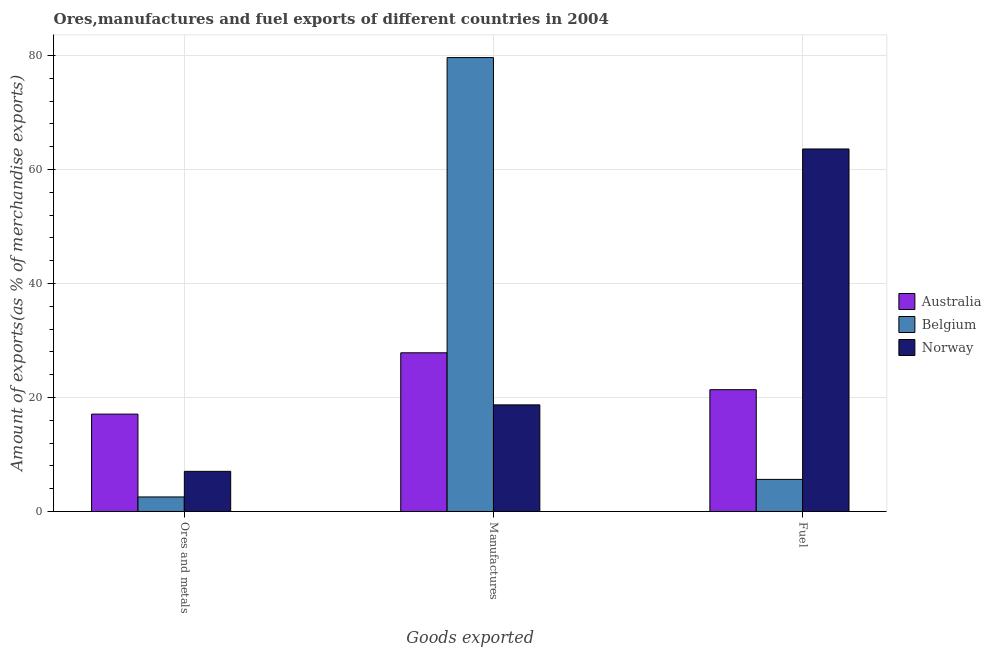How many groups of bars are there?
Offer a terse response. 3. Are the number of bars per tick equal to the number of legend labels?
Your answer should be very brief. Yes. How many bars are there on the 1st tick from the right?
Give a very brief answer. 3. What is the label of the 1st group of bars from the left?
Provide a short and direct response. Ores and metals. What is the percentage of fuel exports in Belgium?
Make the answer very short. 5.63. Across all countries, what is the maximum percentage of manufactures exports?
Your answer should be compact. 79.65. Across all countries, what is the minimum percentage of manufactures exports?
Your answer should be compact. 18.71. In which country was the percentage of manufactures exports maximum?
Ensure brevity in your answer.  Belgium. In which country was the percentage of ores and metals exports minimum?
Give a very brief answer. Belgium. What is the total percentage of fuel exports in the graph?
Ensure brevity in your answer.  90.62. What is the difference between the percentage of manufactures exports in Norway and that in Australia?
Make the answer very short. -9.14. What is the difference between the percentage of manufactures exports in Norway and the percentage of ores and metals exports in Belgium?
Keep it short and to the point. 16.16. What is the average percentage of ores and metals exports per country?
Offer a terse response. 8.89. What is the difference between the percentage of ores and metals exports and percentage of manufactures exports in Norway?
Make the answer very short. -11.66. What is the ratio of the percentage of fuel exports in Belgium to that in Norway?
Your answer should be compact. 0.09. Is the difference between the percentage of ores and metals exports in Australia and Belgium greater than the difference between the percentage of fuel exports in Australia and Belgium?
Your response must be concise. No. What is the difference between the highest and the second highest percentage of ores and metals exports?
Your answer should be compact. 10.04. What is the difference between the highest and the lowest percentage of fuel exports?
Provide a succinct answer. 57.98. Is the sum of the percentage of fuel exports in Norway and Belgium greater than the maximum percentage of ores and metals exports across all countries?
Offer a very short reply. Yes. What does the 3rd bar from the right in Manufactures represents?
Keep it short and to the point. Australia. Are all the bars in the graph horizontal?
Your answer should be compact. No. How many countries are there in the graph?
Make the answer very short. 3. What is the difference between two consecutive major ticks on the Y-axis?
Provide a short and direct response. 20. Does the graph contain any zero values?
Give a very brief answer. No. How many legend labels are there?
Provide a short and direct response. 3. How are the legend labels stacked?
Offer a terse response. Vertical. What is the title of the graph?
Make the answer very short. Ores,manufactures and fuel exports of different countries in 2004. What is the label or title of the X-axis?
Your response must be concise. Goods exported. What is the label or title of the Y-axis?
Provide a succinct answer. Amount of exports(as % of merchandise exports). What is the Amount of exports(as % of merchandise exports) of Australia in Ores and metals?
Offer a terse response. 17.09. What is the Amount of exports(as % of merchandise exports) of Belgium in Ores and metals?
Offer a terse response. 2.55. What is the Amount of exports(as % of merchandise exports) of Norway in Ores and metals?
Provide a short and direct response. 7.05. What is the Amount of exports(as % of merchandise exports) in Australia in Manufactures?
Ensure brevity in your answer.  27.85. What is the Amount of exports(as % of merchandise exports) in Belgium in Manufactures?
Make the answer very short. 79.65. What is the Amount of exports(as % of merchandise exports) in Norway in Manufactures?
Your response must be concise. 18.71. What is the Amount of exports(as % of merchandise exports) of Australia in Fuel?
Your response must be concise. 21.37. What is the Amount of exports(as % of merchandise exports) in Belgium in Fuel?
Make the answer very short. 5.63. What is the Amount of exports(as % of merchandise exports) in Norway in Fuel?
Provide a succinct answer. 63.61. Across all Goods exported, what is the maximum Amount of exports(as % of merchandise exports) of Australia?
Keep it short and to the point. 27.85. Across all Goods exported, what is the maximum Amount of exports(as % of merchandise exports) in Belgium?
Keep it short and to the point. 79.65. Across all Goods exported, what is the maximum Amount of exports(as % of merchandise exports) in Norway?
Offer a terse response. 63.61. Across all Goods exported, what is the minimum Amount of exports(as % of merchandise exports) in Australia?
Your response must be concise. 17.09. Across all Goods exported, what is the minimum Amount of exports(as % of merchandise exports) of Belgium?
Offer a terse response. 2.55. Across all Goods exported, what is the minimum Amount of exports(as % of merchandise exports) of Norway?
Your answer should be very brief. 7.05. What is the total Amount of exports(as % of merchandise exports) in Australia in the graph?
Give a very brief answer. 66.31. What is the total Amount of exports(as % of merchandise exports) of Belgium in the graph?
Your answer should be compact. 87.84. What is the total Amount of exports(as % of merchandise exports) in Norway in the graph?
Provide a short and direct response. 89.37. What is the difference between the Amount of exports(as % of merchandise exports) of Australia in Ores and metals and that in Manufactures?
Offer a very short reply. -10.76. What is the difference between the Amount of exports(as % of merchandise exports) in Belgium in Ores and metals and that in Manufactures?
Your response must be concise. -77.1. What is the difference between the Amount of exports(as % of merchandise exports) of Norway in Ores and metals and that in Manufactures?
Give a very brief answer. -11.66. What is the difference between the Amount of exports(as % of merchandise exports) in Australia in Ores and metals and that in Fuel?
Provide a succinct answer. -4.29. What is the difference between the Amount of exports(as % of merchandise exports) of Belgium in Ores and metals and that in Fuel?
Keep it short and to the point. -3.08. What is the difference between the Amount of exports(as % of merchandise exports) of Norway in Ores and metals and that in Fuel?
Your response must be concise. -56.57. What is the difference between the Amount of exports(as % of merchandise exports) in Australia in Manufactures and that in Fuel?
Your answer should be compact. 6.48. What is the difference between the Amount of exports(as % of merchandise exports) in Belgium in Manufactures and that in Fuel?
Your response must be concise. 74.02. What is the difference between the Amount of exports(as % of merchandise exports) in Norway in Manufactures and that in Fuel?
Ensure brevity in your answer.  -44.9. What is the difference between the Amount of exports(as % of merchandise exports) in Australia in Ores and metals and the Amount of exports(as % of merchandise exports) in Belgium in Manufactures?
Offer a very short reply. -62.57. What is the difference between the Amount of exports(as % of merchandise exports) of Australia in Ores and metals and the Amount of exports(as % of merchandise exports) of Norway in Manufactures?
Provide a succinct answer. -1.62. What is the difference between the Amount of exports(as % of merchandise exports) of Belgium in Ores and metals and the Amount of exports(as % of merchandise exports) of Norway in Manufactures?
Make the answer very short. -16.16. What is the difference between the Amount of exports(as % of merchandise exports) in Australia in Ores and metals and the Amount of exports(as % of merchandise exports) in Belgium in Fuel?
Keep it short and to the point. 11.45. What is the difference between the Amount of exports(as % of merchandise exports) in Australia in Ores and metals and the Amount of exports(as % of merchandise exports) in Norway in Fuel?
Your response must be concise. -46.53. What is the difference between the Amount of exports(as % of merchandise exports) of Belgium in Ores and metals and the Amount of exports(as % of merchandise exports) of Norway in Fuel?
Your answer should be compact. -61.06. What is the difference between the Amount of exports(as % of merchandise exports) of Australia in Manufactures and the Amount of exports(as % of merchandise exports) of Belgium in Fuel?
Ensure brevity in your answer.  22.21. What is the difference between the Amount of exports(as % of merchandise exports) of Australia in Manufactures and the Amount of exports(as % of merchandise exports) of Norway in Fuel?
Give a very brief answer. -35.77. What is the difference between the Amount of exports(as % of merchandise exports) of Belgium in Manufactures and the Amount of exports(as % of merchandise exports) of Norway in Fuel?
Your response must be concise. 16.04. What is the average Amount of exports(as % of merchandise exports) in Australia per Goods exported?
Give a very brief answer. 22.1. What is the average Amount of exports(as % of merchandise exports) of Belgium per Goods exported?
Make the answer very short. 29.28. What is the average Amount of exports(as % of merchandise exports) in Norway per Goods exported?
Provide a short and direct response. 29.79. What is the difference between the Amount of exports(as % of merchandise exports) of Australia and Amount of exports(as % of merchandise exports) of Belgium in Ores and metals?
Provide a short and direct response. 14.53. What is the difference between the Amount of exports(as % of merchandise exports) in Australia and Amount of exports(as % of merchandise exports) in Norway in Ores and metals?
Offer a terse response. 10.04. What is the difference between the Amount of exports(as % of merchandise exports) in Belgium and Amount of exports(as % of merchandise exports) in Norway in Ores and metals?
Offer a terse response. -4.49. What is the difference between the Amount of exports(as % of merchandise exports) of Australia and Amount of exports(as % of merchandise exports) of Belgium in Manufactures?
Make the answer very short. -51.81. What is the difference between the Amount of exports(as % of merchandise exports) of Australia and Amount of exports(as % of merchandise exports) of Norway in Manufactures?
Your answer should be very brief. 9.14. What is the difference between the Amount of exports(as % of merchandise exports) in Belgium and Amount of exports(as % of merchandise exports) in Norway in Manufactures?
Provide a succinct answer. 60.94. What is the difference between the Amount of exports(as % of merchandise exports) in Australia and Amount of exports(as % of merchandise exports) in Belgium in Fuel?
Provide a short and direct response. 15.74. What is the difference between the Amount of exports(as % of merchandise exports) in Australia and Amount of exports(as % of merchandise exports) in Norway in Fuel?
Ensure brevity in your answer.  -42.24. What is the difference between the Amount of exports(as % of merchandise exports) of Belgium and Amount of exports(as % of merchandise exports) of Norway in Fuel?
Your answer should be compact. -57.98. What is the ratio of the Amount of exports(as % of merchandise exports) in Australia in Ores and metals to that in Manufactures?
Make the answer very short. 0.61. What is the ratio of the Amount of exports(as % of merchandise exports) in Belgium in Ores and metals to that in Manufactures?
Ensure brevity in your answer.  0.03. What is the ratio of the Amount of exports(as % of merchandise exports) of Norway in Ores and metals to that in Manufactures?
Your answer should be compact. 0.38. What is the ratio of the Amount of exports(as % of merchandise exports) in Australia in Ores and metals to that in Fuel?
Provide a succinct answer. 0.8. What is the ratio of the Amount of exports(as % of merchandise exports) of Belgium in Ores and metals to that in Fuel?
Offer a very short reply. 0.45. What is the ratio of the Amount of exports(as % of merchandise exports) in Norway in Ores and metals to that in Fuel?
Give a very brief answer. 0.11. What is the ratio of the Amount of exports(as % of merchandise exports) of Australia in Manufactures to that in Fuel?
Keep it short and to the point. 1.3. What is the ratio of the Amount of exports(as % of merchandise exports) of Belgium in Manufactures to that in Fuel?
Offer a terse response. 14.14. What is the ratio of the Amount of exports(as % of merchandise exports) in Norway in Manufactures to that in Fuel?
Offer a terse response. 0.29. What is the difference between the highest and the second highest Amount of exports(as % of merchandise exports) in Australia?
Offer a very short reply. 6.48. What is the difference between the highest and the second highest Amount of exports(as % of merchandise exports) of Belgium?
Provide a succinct answer. 74.02. What is the difference between the highest and the second highest Amount of exports(as % of merchandise exports) in Norway?
Your response must be concise. 44.9. What is the difference between the highest and the lowest Amount of exports(as % of merchandise exports) in Australia?
Offer a terse response. 10.76. What is the difference between the highest and the lowest Amount of exports(as % of merchandise exports) of Belgium?
Give a very brief answer. 77.1. What is the difference between the highest and the lowest Amount of exports(as % of merchandise exports) of Norway?
Your response must be concise. 56.57. 